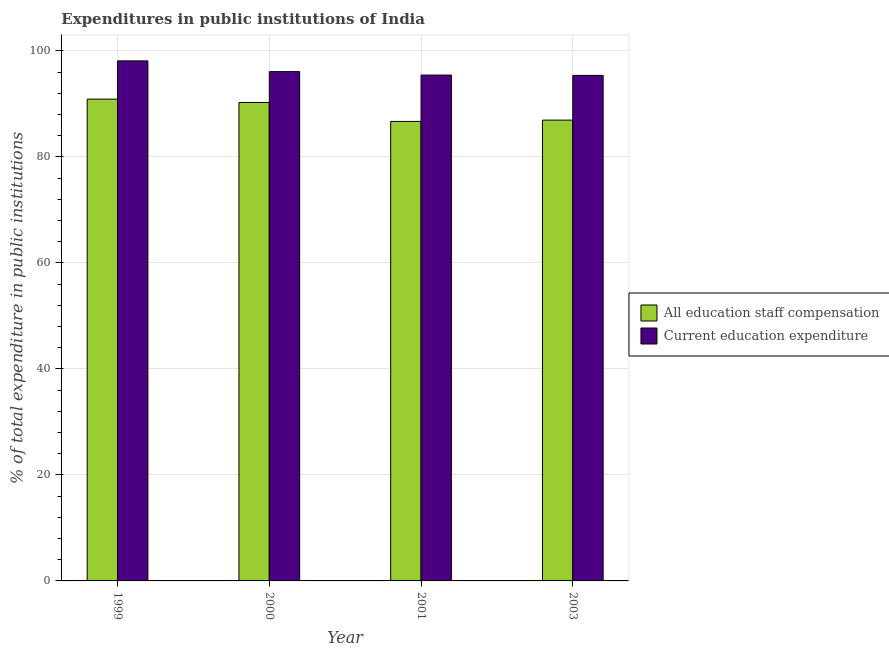How many bars are there on the 2nd tick from the right?
Make the answer very short. 2. In how many cases, is the number of bars for a given year not equal to the number of legend labels?
Keep it short and to the point. 0. What is the expenditure in staff compensation in 1999?
Keep it short and to the point. 90.92. Across all years, what is the maximum expenditure in staff compensation?
Provide a succinct answer. 90.92. Across all years, what is the minimum expenditure in staff compensation?
Give a very brief answer. 86.71. In which year was the expenditure in staff compensation minimum?
Offer a very short reply. 2001. What is the total expenditure in staff compensation in the graph?
Make the answer very short. 354.87. What is the difference between the expenditure in staff compensation in 1999 and that in 2003?
Provide a short and direct response. 3.96. What is the difference between the expenditure in staff compensation in 2000 and the expenditure in education in 2003?
Your answer should be very brief. 3.33. What is the average expenditure in education per year?
Offer a terse response. 96.27. In how many years, is the expenditure in staff compensation greater than 8 %?
Offer a terse response. 4. What is the ratio of the expenditure in education in 1999 to that in 2000?
Make the answer very short. 1.02. Is the expenditure in education in 2000 less than that in 2001?
Your answer should be compact. No. What is the difference between the highest and the second highest expenditure in staff compensation?
Provide a succinct answer. 0.63. What is the difference between the highest and the lowest expenditure in education?
Offer a very short reply. 2.73. In how many years, is the expenditure in education greater than the average expenditure in education taken over all years?
Offer a very short reply. 1. Is the sum of the expenditure in education in 2001 and 2003 greater than the maximum expenditure in staff compensation across all years?
Keep it short and to the point. Yes. What does the 2nd bar from the left in 1999 represents?
Your response must be concise. Current education expenditure. What does the 1st bar from the right in 2000 represents?
Make the answer very short. Current education expenditure. How many bars are there?
Make the answer very short. 8. Are all the bars in the graph horizontal?
Provide a succinct answer. No. How many years are there in the graph?
Provide a short and direct response. 4. Does the graph contain any zero values?
Make the answer very short. No. Does the graph contain grids?
Give a very brief answer. Yes. Where does the legend appear in the graph?
Offer a terse response. Center right. What is the title of the graph?
Make the answer very short. Expenditures in public institutions of India. What is the label or title of the Y-axis?
Provide a succinct answer. % of total expenditure in public institutions. What is the % of total expenditure in public institutions of All education staff compensation in 1999?
Keep it short and to the point. 90.92. What is the % of total expenditure in public institutions in Current education expenditure in 1999?
Offer a very short reply. 98.13. What is the % of total expenditure in public institutions in All education staff compensation in 2000?
Give a very brief answer. 90.29. What is the % of total expenditure in public institutions of Current education expenditure in 2000?
Your answer should be very brief. 96.11. What is the % of total expenditure in public institutions of All education staff compensation in 2001?
Provide a short and direct response. 86.71. What is the % of total expenditure in public institutions in Current education expenditure in 2001?
Offer a terse response. 95.45. What is the % of total expenditure in public institutions of All education staff compensation in 2003?
Make the answer very short. 86.95. What is the % of total expenditure in public institutions in Current education expenditure in 2003?
Provide a succinct answer. 95.4. Across all years, what is the maximum % of total expenditure in public institutions in All education staff compensation?
Your answer should be compact. 90.92. Across all years, what is the maximum % of total expenditure in public institutions in Current education expenditure?
Your answer should be very brief. 98.13. Across all years, what is the minimum % of total expenditure in public institutions in All education staff compensation?
Give a very brief answer. 86.71. Across all years, what is the minimum % of total expenditure in public institutions of Current education expenditure?
Keep it short and to the point. 95.4. What is the total % of total expenditure in public institutions of All education staff compensation in the graph?
Provide a short and direct response. 354.87. What is the total % of total expenditure in public institutions of Current education expenditure in the graph?
Your answer should be very brief. 385.09. What is the difference between the % of total expenditure in public institutions of All education staff compensation in 1999 and that in 2000?
Your answer should be very brief. 0.63. What is the difference between the % of total expenditure in public institutions of Current education expenditure in 1999 and that in 2000?
Your response must be concise. 2.03. What is the difference between the % of total expenditure in public institutions of All education staff compensation in 1999 and that in 2001?
Provide a short and direct response. 4.21. What is the difference between the % of total expenditure in public institutions of Current education expenditure in 1999 and that in 2001?
Give a very brief answer. 2.68. What is the difference between the % of total expenditure in public institutions in All education staff compensation in 1999 and that in 2003?
Your response must be concise. 3.96. What is the difference between the % of total expenditure in public institutions in Current education expenditure in 1999 and that in 2003?
Ensure brevity in your answer.  2.73. What is the difference between the % of total expenditure in public institutions in All education staff compensation in 2000 and that in 2001?
Offer a terse response. 3.58. What is the difference between the % of total expenditure in public institutions of Current education expenditure in 2000 and that in 2001?
Provide a succinct answer. 0.65. What is the difference between the % of total expenditure in public institutions in All education staff compensation in 2000 and that in 2003?
Ensure brevity in your answer.  3.33. What is the difference between the % of total expenditure in public institutions in Current education expenditure in 2000 and that in 2003?
Your response must be concise. 0.71. What is the difference between the % of total expenditure in public institutions in All education staff compensation in 2001 and that in 2003?
Your answer should be very brief. -0.24. What is the difference between the % of total expenditure in public institutions of Current education expenditure in 2001 and that in 2003?
Offer a terse response. 0.05. What is the difference between the % of total expenditure in public institutions of All education staff compensation in 1999 and the % of total expenditure in public institutions of Current education expenditure in 2000?
Your answer should be very brief. -5.19. What is the difference between the % of total expenditure in public institutions in All education staff compensation in 1999 and the % of total expenditure in public institutions in Current education expenditure in 2001?
Keep it short and to the point. -4.53. What is the difference between the % of total expenditure in public institutions in All education staff compensation in 1999 and the % of total expenditure in public institutions in Current education expenditure in 2003?
Give a very brief answer. -4.48. What is the difference between the % of total expenditure in public institutions of All education staff compensation in 2000 and the % of total expenditure in public institutions of Current education expenditure in 2001?
Offer a very short reply. -5.17. What is the difference between the % of total expenditure in public institutions of All education staff compensation in 2000 and the % of total expenditure in public institutions of Current education expenditure in 2003?
Offer a terse response. -5.11. What is the difference between the % of total expenditure in public institutions in All education staff compensation in 2001 and the % of total expenditure in public institutions in Current education expenditure in 2003?
Offer a terse response. -8.69. What is the average % of total expenditure in public institutions of All education staff compensation per year?
Provide a succinct answer. 88.72. What is the average % of total expenditure in public institutions of Current education expenditure per year?
Provide a short and direct response. 96.27. In the year 1999, what is the difference between the % of total expenditure in public institutions in All education staff compensation and % of total expenditure in public institutions in Current education expenditure?
Your answer should be compact. -7.22. In the year 2000, what is the difference between the % of total expenditure in public institutions in All education staff compensation and % of total expenditure in public institutions in Current education expenditure?
Offer a terse response. -5.82. In the year 2001, what is the difference between the % of total expenditure in public institutions of All education staff compensation and % of total expenditure in public institutions of Current education expenditure?
Offer a very short reply. -8.74. In the year 2003, what is the difference between the % of total expenditure in public institutions of All education staff compensation and % of total expenditure in public institutions of Current education expenditure?
Your answer should be compact. -8.45. What is the ratio of the % of total expenditure in public institutions in Current education expenditure in 1999 to that in 2000?
Ensure brevity in your answer.  1.02. What is the ratio of the % of total expenditure in public institutions in All education staff compensation in 1999 to that in 2001?
Give a very brief answer. 1.05. What is the ratio of the % of total expenditure in public institutions of Current education expenditure in 1999 to that in 2001?
Make the answer very short. 1.03. What is the ratio of the % of total expenditure in public institutions in All education staff compensation in 1999 to that in 2003?
Make the answer very short. 1.05. What is the ratio of the % of total expenditure in public institutions of Current education expenditure in 1999 to that in 2003?
Your response must be concise. 1.03. What is the ratio of the % of total expenditure in public institutions of All education staff compensation in 2000 to that in 2001?
Ensure brevity in your answer.  1.04. What is the ratio of the % of total expenditure in public institutions in Current education expenditure in 2000 to that in 2001?
Provide a short and direct response. 1.01. What is the ratio of the % of total expenditure in public institutions of All education staff compensation in 2000 to that in 2003?
Make the answer very short. 1.04. What is the ratio of the % of total expenditure in public institutions in Current education expenditure in 2000 to that in 2003?
Offer a very short reply. 1.01. What is the difference between the highest and the second highest % of total expenditure in public institutions of All education staff compensation?
Offer a terse response. 0.63. What is the difference between the highest and the second highest % of total expenditure in public institutions of Current education expenditure?
Your answer should be very brief. 2.03. What is the difference between the highest and the lowest % of total expenditure in public institutions in All education staff compensation?
Your response must be concise. 4.21. What is the difference between the highest and the lowest % of total expenditure in public institutions in Current education expenditure?
Make the answer very short. 2.73. 